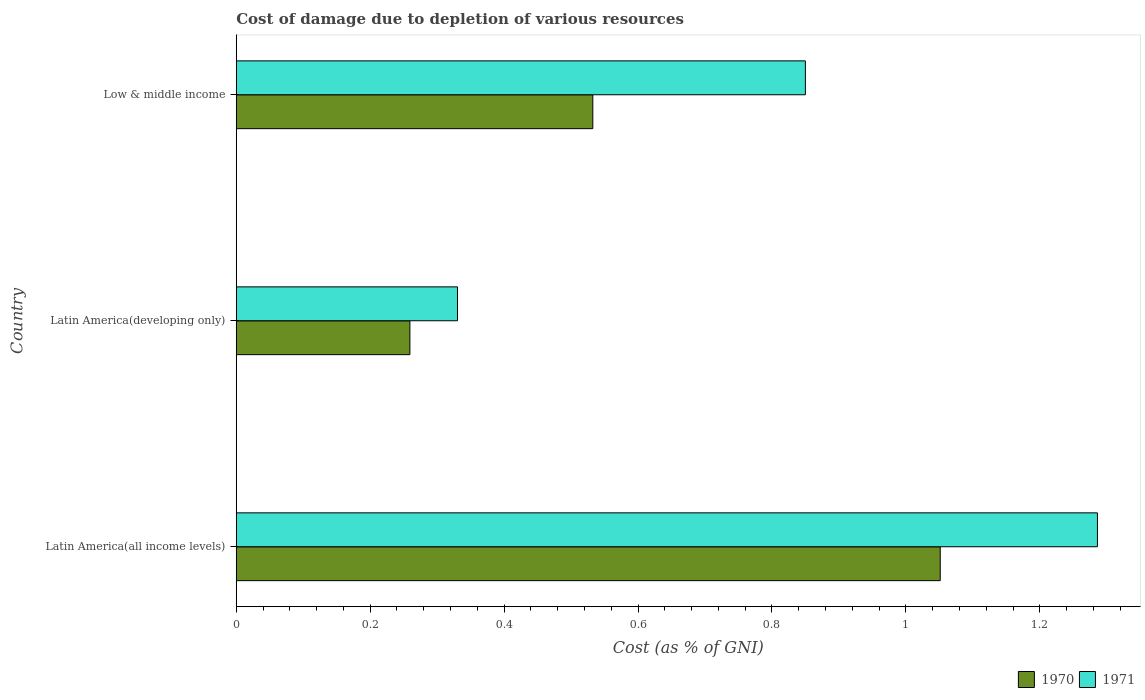How many different coloured bars are there?
Make the answer very short. 2. Are the number of bars per tick equal to the number of legend labels?
Your response must be concise. Yes. How many bars are there on the 1st tick from the top?
Your answer should be compact. 2. What is the label of the 3rd group of bars from the top?
Make the answer very short. Latin America(all income levels). What is the cost of damage caused due to the depletion of various resources in 1971 in Latin America(all income levels)?
Give a very brief answer. 1.29. Across all countries, what is the maximum cost of damage caused due to the depletion of various resources in 1971?
Ensure brevity in your answer.  1.29. Across all countries, what is the minimum cost of damage caused due to the depletion of various resources in 1971?
Ensure brevity in your answer.  0.33. In which country was the cost of damage caused due to the depletion of various resources in 1970 maximum?
Your response must be concise. Latin America(all income levels). In which country was the cost of damage caused due to the depletion of various resources in 1970 minimum?
Your answer should be very brief. Latin America(developing only). What is the total cost of damage caused due to the depletion of various resources in 1971 in the graph?
Your answer should be very brief. 2.47. What is the difference between the cost of damage caused due to the depletion of various resources in 1971 in Latin America(all income levels) and that in Low & middle income?
Provide a succinct answer. 0.44. What is the difference between the cost of damage caused due to the depletion of various resources in 1970 in Latin America(all income levels) and the cost of damage caused due to the depletion of various resources in 1971 in Latin America(developing only)?
Provide a short and direct response. 0.72. What is the average cost of damage caused due to the depletion of various resources in 1970 per country?
Your response must be concise. 0.61. What is the difference between the cost of damage caused due to the depletion of various resources in 1970 and cost of damage caused due to the depletion of various resources in 1971 in Low & middle income?
Offer a terse response. -0.32. What is the ratio of the cost of damage caused due to the depletion of various resources in 1970 in Latin America(developing only) to that in Low & middle income?
Provide a succinct answer. 0.49. Is the cost of damage caused due to the depletion of various resources in 1971 in Latin America(developing only) less than that in Low & middle income?
Your answer should be compact. Yes. Is the difference between the cost of damage caused due to the depletion of various resources in 1970 in Latin America(all income levels) and Low & middle income greater than the difference between the cost of damage caused due to the depletion of various resources in 1971 in Latin America(all income levels) and Low & middle income?
Keep it short and to the point. Yes. What is the difference between the highest and the second highest cost of damage caused due to the depletion of various resources in 1970?
Your answer should be compact. 0.52. What is the difference between the highest and the lowest cost of damage caused due to the depletion of various resources in 1971?
Your answer should be compact. 0.96. In how many countries, is the cost of damage caused due to the depletion of various resources in 1970 greater than the average cost of damage caused due to the depletion of various resources in 1970 taken over all countries?
Your response must be concise. 1. What does the 2nd bar from the bottom in Low & middle income represents?
Your answer should be compact. 1971. Are all the bars in the graph horizontal?
Your response must be concise. Yes. What is the difference between two consecutive major ticks on the X-axis?
Your response must be concise. 0.2. Are the values on the major ticks of X-axis written in scientific E-notation?
Your response must be concise. No. Where does the legend appear in the graph?
Offer a very short reply. Bottom right. How many legend labels are there?
Provide a short and direct response. 2. How are the legend labels stacked?
Make the answer very short. Horizontal. What is the title of the graph?
Provide a succinct answer. Cost of damage due to depletion of various resources. Does "1985" appear as one of the legend labels in the graph?
Ensure brevity in your answer.  No. What is the label or title of the X-axis?
Keep it short and to the point. Cost (as % of GNI). What is the label or title of the Y-axis?
Your answer should be compact. Country. What is the Cost (as % of GNI) of 1970 in Latin America(all income levels)?
Make the answer very short. 1.05. What is the Cost (as % of GNI) in 1971 in Latin America(all income levels)?
Provide a short and direct response. 1.29. What is the Cost (as % of GNI) of 1970 in Latin America(developing only)?
Your answer should be compact. 0.26. What is the Cost (as % of GNI) of 1971 in Latin America(developing only)?
Keep it short and to the point. 0.33. What is the Cost (as % of GNI) of 1970 in Low & middle income?
Give a very brief answer. 0.53. What is the Cost (as % of GNI) of 1971 in Low & middle income?
Provide a succinct answer. 0.85. Across all countries, what is the maximum Cost (as % of GNI) of 1970?
Make the answer very short. 1.05. Across all countries, what is the maximum Cost (as % of GNI) in 1971?
Make the answer very short. 1.29. Across all countries, what is the minimum Cost (as % of GNI) in 1970?
Provide a succinct answer. 0.26. Across all countries, what is the minimum Cost (as % of GNI) in 1971?
Your response must be concise. 0.33. What is the total Cost (as % of GNI) of 1970 in the graph?
Your answer should be very brief. 1.84. What is the total Cost (as % of GNI) in 1971 in the graph?
Ensure brevity in your answer.  2.47. What is the difference between the Cost (as % of GNI) of 1970 in Latin America(all income levels) and that in Latin America(developing only)?
Your answer should be very brief. 0.79. What is the difference between the Cost (as % of GNI) in 1971 in Latin America(all income levels) and that in Latin America(developing only)?
Ensure brevity in your answer.  0.96. What is the difference between the Cost (as % of GNI) in 1970 in Latin America(all income levels) and that in Low & middle income?
Provide a succinct answer. 0.52. What is the difference between the Cost (as % of GNI) of 1971 in Latin America(all income levels) and that in Low & middle income?
Your answer should be compact. 0.44. What is the difference between the Cost (as % of GNI) in 1970 in Latin America(developing only) and that in Low & middle income?
Offer a terse response. -0.27. What is the difference between the Cost (as % of GNI) of 1971 in Latin America(developing only) and that in Low & middle income?
Your answer should be compact. -0.52. What is the difference between the Cost (as % of GNI) of 1970 in Latin America(all income levels) and the Cost (as % of GNI) of 1971 in Latin America(developing only)?
Offer a terse response. 0.72. What is the difference between the Cost (as % of GNI) of 1970 in Latin America(all income levels) and the Cost (as % of GNI) of 1971 in Low & middle income?
Provide a short and direct response. 0.2. What is the difference between the Cost (as % of GNI) of 1970 in Latin America(developing only) and the Cost (as % of GNI) of 1971 in Low & middle income?
Your answer should be compact. -0.59. What is the average Cost (as % of GNI) in 1970 per country?
Make the answer very short. 0.61. What is the average Cost (as % of GNI) in 1971 per country?
Your response must be concise. 0.82. What is the difference between the Cost (as % of GNI) of 1970 and Cost (as % of GNI) of 1971 in Latin America(all income levels)?
Offer a very short reply. -0.23. What is the difference between the Cost (as % of GNI) in 1970 and Cost (as % of GNI) in 1971 in Latin America(developing only)?
Your answer should be very brief. -0.07. What is the difference between the Cost (as % of GNI) in 1970 and Cost (as % of GNI) in 1971 in Low & middle income?
Offer a terse response. -0.32. What is the ratio of the Cost (as % of GNI) of 1970 in Latin America(all income levels) to that in Latin America(developing only)?
Offer a terse response. 4.05. What is the ratio of the Cost (as % of GNI) of 1971 in Latin America(all income levels) to that in Latin America(developing only)?
Your response must be concise. 3.89. What is the ratio of the Cost (as % of GNI) of 1970 in Latin America(all income levels) to that in Low & middle income?
Provide a short and direct response. 1.97. What is the ratio of the Cost (as % of GNI) of 1971 in Latin America(all income levels) to that in Low & middle income?
Provide a succinct answer. 1.51. What is the ratio of the Cost (as % of GNI) of 1970 in Latin America(developing only) to that in Low & middle income?
Offer a very short reply. 0.49. What is the ratio of the Cost (as % of GNI) of 1971 in Latin America(developing only) to that in Low & middle income?
Offer a very short reply. 0.39. What is the difference between the highest and the second highest Cost (as % of GNI) of 1970?
Keep it short and to the point. 0.52. What is the difference between the highest and the second highest Cost (as % of GNI) in 1971?
Your answer should be very brief. 0.44. What is the difference between the highest and the lowest Cost (as % of GNI) in 1970?
Your answer should be very brief. 0.79. What is the difference between the highest and the lowest Cost (as % of GNI) of 1971?
Keep it short and to the point. 0.96. 